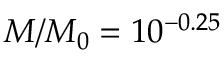<formula> <loc_0><loc_0><loc_500><loc_500>M / M _ { 0 } = 1 0 ^ { - 0 . 2 5 }</formula> 